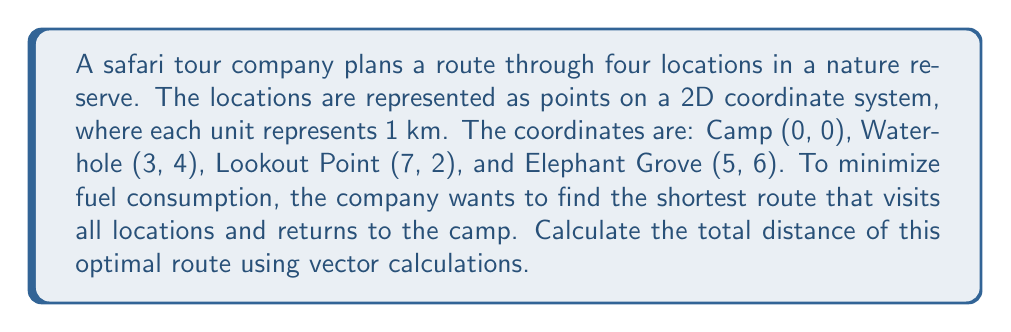Show me your answer to this math problem. Let's approach this step-by-step:

1) First, we need to represent each location as a vector from the origin:
   Camp: $\vec{C} = \begin{pmatrix} 0 \\ 0 \end{pmatrix}$
   Waterhole: $\vec{W} = \begin{pmatrix} 3 \\ 4 \end{pmatrix}$
   Lookout Point: $\vec{L} = \begin{pmatrix} 7 \\ 2 \end{pmatrix}$
   Elephant Grove: $\vec{E} = \begin{pmatrix} 5 \\ 6 \end{pmatrix}$

2) To find the shortest route, we need to calculate the distances between each pair of points and then determine the optimal order.

3) The distance between two points can be calculated using the magnitude of the difference vector:
   $d = \|\vec{a} - \vec{b}\| = \sqrt{(a_x - b_x)^2 + (a_y - b_y)^2}$

4) Let's calculate all possible distances:
   C to W: $\|\vec{W} - \vec{C}\| = \sqrt{3^2 + 4^2} = 5$ km
   C to L: $\|\vec{L} - \vec{C}\| = \sqrt{7^2 + 2^2} = \sqrt{53}$ km
   C to E: $\|\vec{E} - \vec{C}\| = \sqrt{5^2 + 6^2} = \sqrt{61}$ km
   W to L: $\|\vec{L} - \vec{W}\| = \sqrt{4^2 + (-2)^2} = \sqrt{20}$ km
   W to E: $\|\vec{E} - \vec{W}\| = \sqrt{2^2 + 2^2} = 2\sqrt{2}$ km
   L to E: $\|\vec{E} - \vec{L}\| = \sqrt{(-2)^2 + 4^2} = 2\sqrt{5}$ km

5) The optimal route will be the one that minimizes the total distance. By inspection or using an algorithm like the nearest neighbor heuristic, we can determine that the optimal route is:
   Camp → Waterhole → Elephant Grove → Lookout Point → Camp

6) Calculate the total distance:
   $d_{total} = \|\vec{W} - \vec{C}\| + \|\vec{E} - \vec{W}\| + \|\vec{L} - \vec{E}\| + \|\vec{C} - \vec{L}\|$
   $d_{total} = 5 + 2\sqrt{2} + 2\sqrt{5} + \sqrt{53}$ km

7) Simplify:
   $d_{total} = 5 + 2\sqrt{2} + 2\sqrt{5} + \sqrt{53}$ km ≈ 22.07 km
Answer: $5 + 2\sqrt{2} + 2\sqrt{5} + \sqrt{53}$ km 